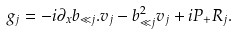<formula> <loc_0><loc_0><loc_500><loc_500>g _ { j } = - i \partial _ { x } b _ { \ll j } . v _ { j } - b _ { \ll j } ^ { 2 } v _ { j } + i P _ { + } R _ { j } .</formula> 